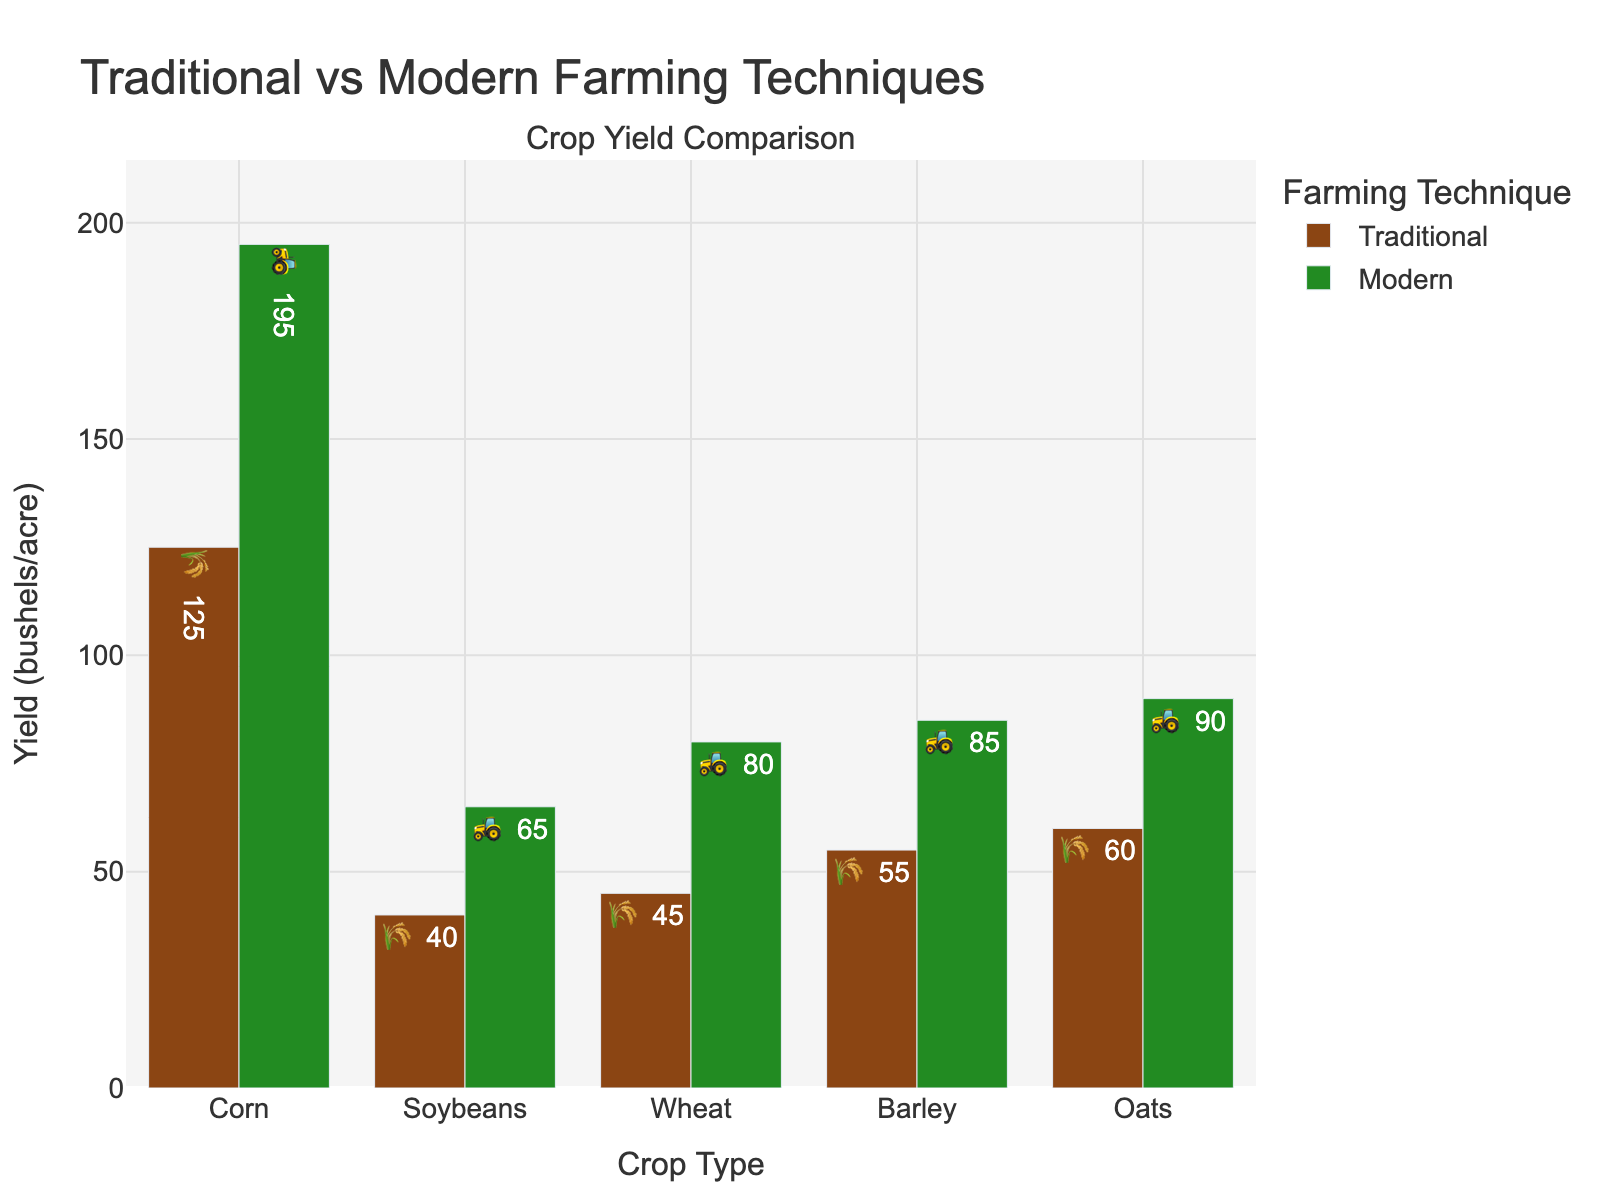What's the title of the chart? The title of the chart is located at the top and provides an overview of the content. It reads "Traditional vs Modern Farming Techniques".
Answer: Traditional vs Modern Farming Techniques What are the different crops listed on the x-axis? The x-axis lists different types of crops, which are Corn, Soybeans, Wheat, Barley, and Oats.
Answer: Corn, Soybeans, Wheat, Barley, Oats Which farming technique yields higher bushels per acre for corn? 🌽 By looking at the bar heights for corn, we see that the Modern farming technique (green bar) is higher than the Traditional one (brown bar). Modern yields 195 bushels per acre, which is higher than Traditional's 125.
Answer: Modern What's the difference in yield between traditional and modern techniques for soybeans? 🌱 Soybeans have a yield of 40 bushels/acre for Traditional and 65 bushels/acre for Modern. The difference is 65 - 40 = 25 bushels/acre.
Answer: 25 bushels/acre For which crop is the yield improvement (from traditional to modern) the greatest? Calculate the yield improvement for each crop (Modern - Traditional) and compare. The improvements are: Corn (70), Soybeans (25), Wheat (35), Barley (30), and Oats (30). Corn has the greatest improvement of 70 bushels/acre.
Answer: Corn Which crop has the smallest yield with traditional farming techniques? Compare the heights of the brown bars. Soybeans have the smallest yield with traditional techniques, at 40 bushels/acre.
Answer: Soybeans How many bushels per acre does modern farming produce for oats? 🌾 Look at the height of the green bar for oats. It shows 90 bushels/acre.
Answer: 90 bushels/acre Is the increase in yield from traditional to modern farming greater for barley or wheat? Calculate the difference for both: Barley (85-55)=30, Wheat (80-45)=35. The increase is greater for Wheat (35 bushels/acre).
Answer: Wheat What's the average yield of traditional farming across all crops? Sum the traditional yields of all crops (125 + 40 + 45 + 55 + 60) = 325 bushels/acre, then divide by the number of crops (5). The average yield is 325/5 = 65 bushels/acre.
Answer: 65 bushels/acre Does any crop have the same difference in yield between traditional and modern techniques? Calculate the yield differences: Corn (70), Soybeans (25), Wheat (35), Barley (30), Oats (30). Both Barley and Oats have the same yield difference of 30 bushels/acre.
Answer: Barley, Oats 